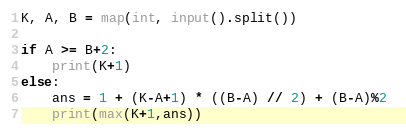Convert code to text. <code><loc_0><loc_0><loc_500><loc_500><_Python_>K, A, B = map(int, input().split())

if A >= B+2:
    print(K+1)
else:
    ans = 1 + (K-A+1) * ((B-A) // 2) + (B-A)%2 
    print(max(K+1,ans))</code> 